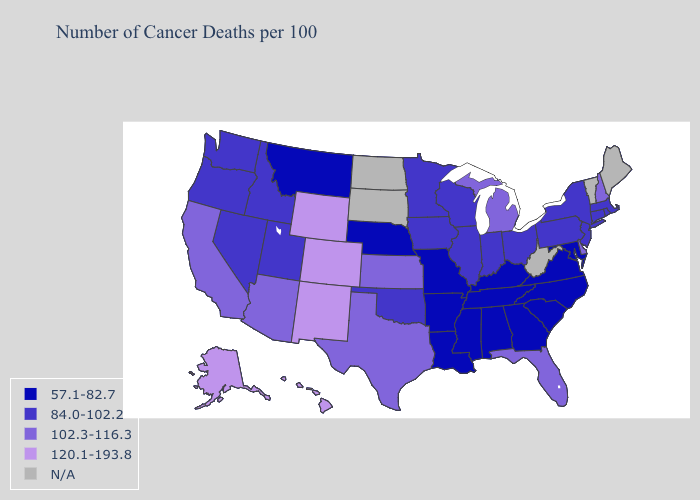Name the states that have a value in the range 120.1-193.8?
Quick response, please. Alaska, Colorado, Hawaii, New Mexico, Wyoming. Name the states that have a value in the range 120.1-193.8?
Quick response, please. Alaska, Colorado, Hawaii, New Mexico, Wyoming. Does New York have the lowest value in the USA?
Write a very short answer. No. What is the value of Georgia?
Write a very short answer. 57.1-82.7. What is the value of Delaware?
Quick response, please. 102.3-116.3. What is the lowest value in states that border Minnesota?
Write a very short answer. 84.0-102.2. Name the states that have a value in the range 102.3-116.3?
Keep it brief. Arizona, California, Delaware, Florida, Kansas, Michigan, New Hampshire, Texas. How many symbols are there in the legend?
Concise answer only. 5. Among the states that border Indiana , does Illinois have the lowest value?
Write a very short answer. No. Does Utah have the lowest value in the USA?
Keep it brief. No. What is the value of Kansas?
Keep it brief. 102.3-116.3. Which states have the lowest value in the West?
Short answer required. Montana. Among the states that border Indiana , which have the highest value?
Quick response, please. Michigan. 